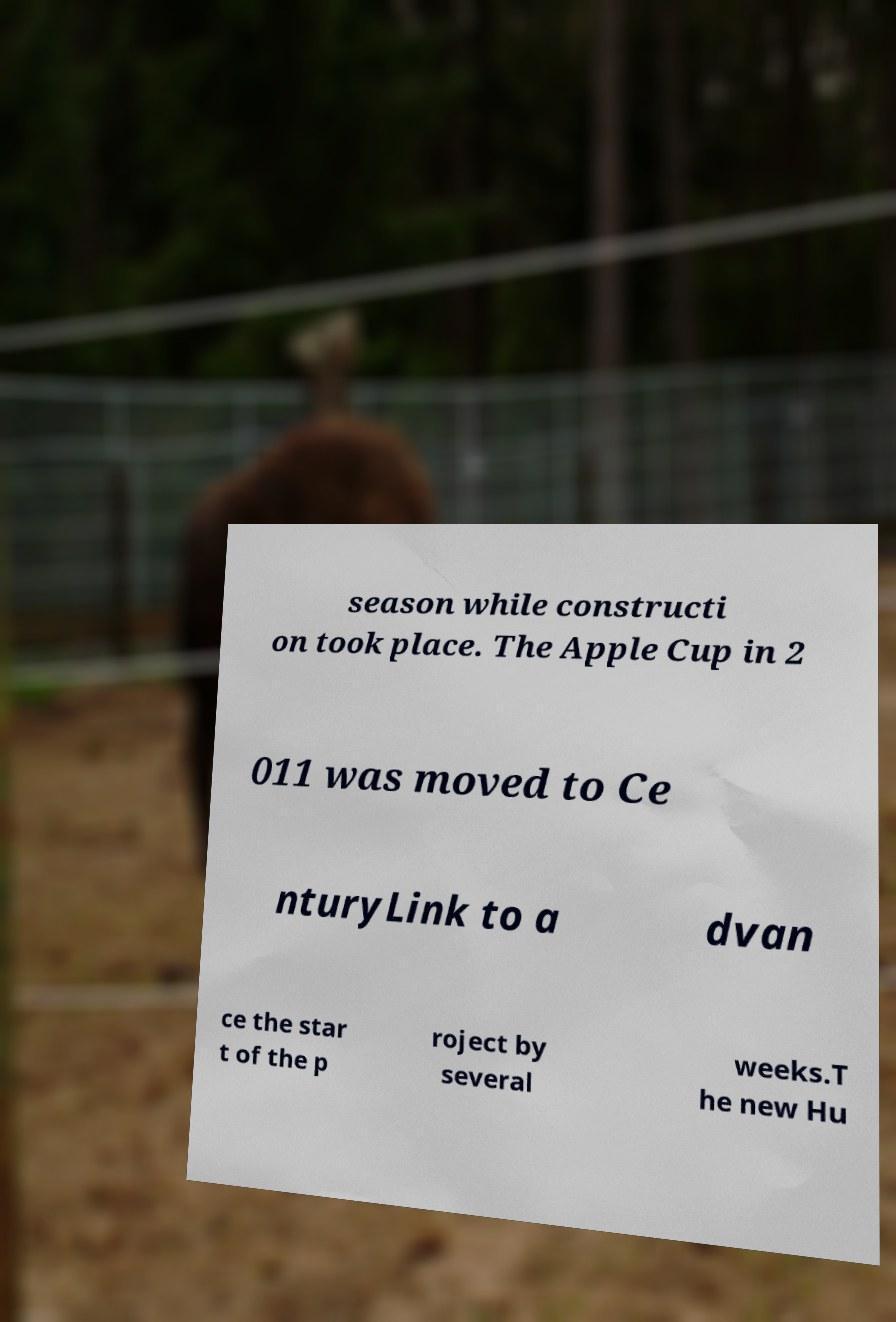Could you extract and type out the text from this image? season while constructi on took place. The Apple Cup in 2 011 was moved to Ce nturyLink to a dvan ce the star t of the p roject by several weeks.T he new Hu 